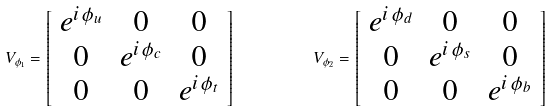<formula> <loc_0><loc_0><loc_500><loc_500>V _ { \phi _ { 1 } } = \left [ \begin{array} { c c c } e ^ { i \, \phi _ { u } } & 0 & 0 \\ 0 & e ^ { i \, \phi _ { c } } & 0 \\ 0 & 0 & e ^ { i \, \phi _ { t } } \\ \end{array} \right ] \quad \ \quad \ V _ { \phi _ { 2 } } = \left [ \begin{array} { c c c } e ^ { i \, \phi _ { d } } & 0 & 0 \\ 0 & e ^ { i \, \phi _ { s } } & 0 \\ 0 & 0 & e ^ { i \, \phi _ { b } } \\ \end{array} \right ]</formula> 